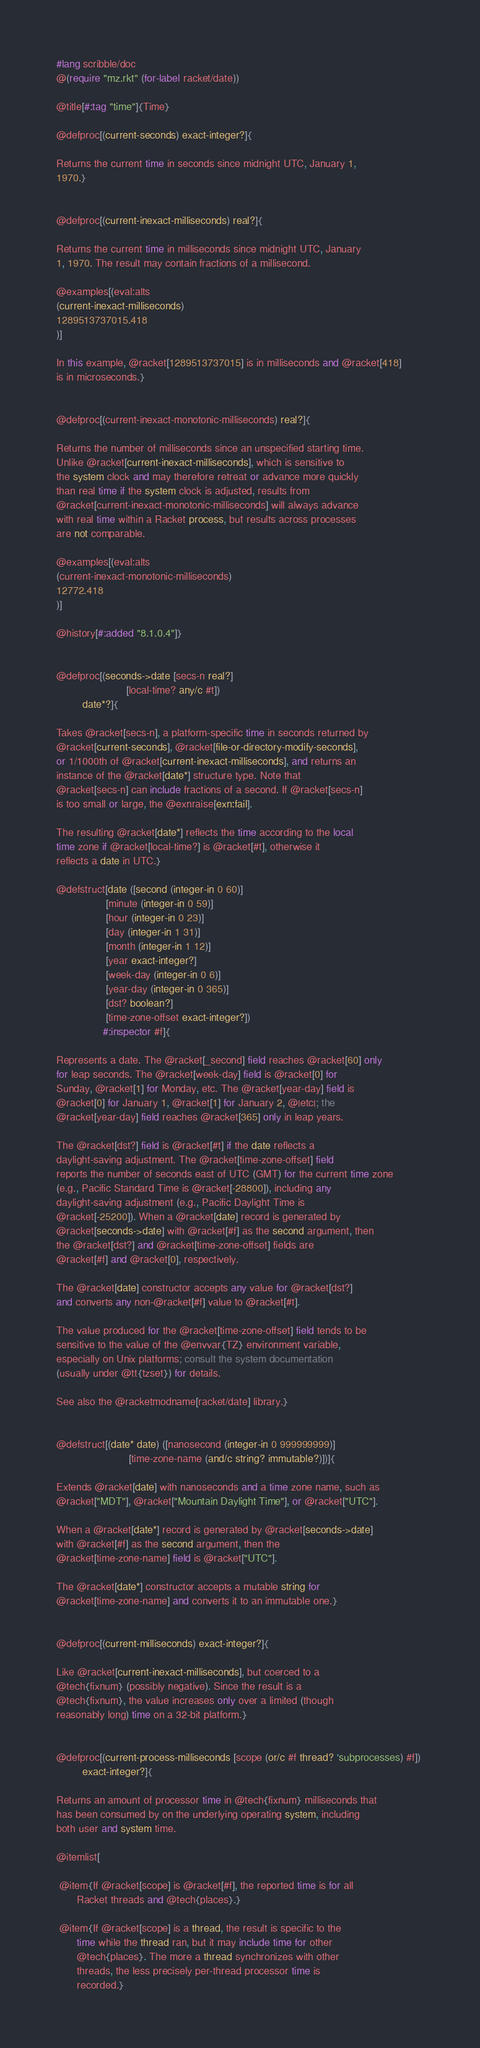<code> <loc_0><loc_0><loc_500><loc_500><_Racket_>#lang scribble/doc
@(require "mz.rkt" (for-label racket/date))

@title[#:tag "time"]{Time}

@defproc[(current-seconds) exact-integer?]{

Returns the current time in seconds since midnight UTC, January 1,
1970.}


@defproc[(current-inexact-milliseconds) real?]{

Returns the current time in milliseconds since midnight UTC, January
1, 1970. The result may contain fractions of a millisecond.

@examples[(eval:alts
(current-inexact-milliseconds)
1289513737015.418
)]

In this example, @racket[1289513737015] is in milliseconds and @racket[418]
is in microseconds.}


@defproc[(current-inexact-monotonic-milliseconds) real?]{

Returns the number of milliseconds since an unspecified starting time.
Unlike @racket[current-inexact-milliseconds], which is sensitive to
the system clock and may therefore retreat or advance more quickly
than real time if the system clock is adjusted, results from
@racket[current-inexact-monotonic-milliseconds] will always advance
with real time within a Racket process, but results across processes
are not comparable.

@examples[(eval:alts
(current-inexact-monotonic-milliseconds)
12772.418
)]

@history[#:added "8.1.0.4"]}


@defproc[(seconds->date [secs-n real?]
                        [local-time? any/c #t])
         date*?]{

Takes @racket[secs-n], a platform-specific time in seconds returned by
@racket[current-seconds], @racket[file-or-directory-modify-seconds],
or 1/1000th of @racket[current-inexact-milliseconds], and returns an
instance of the @racket[date*] structure type. Note that
@racket[secs-n] can include fractions of a second. If @racket[secs-n]
is too small or large, the @exnraise[exn:fail].

The resulting @racket[date*] reflects the time according to the local
time zone if @racket[local-time?] is @racket[#t], otherwise it
reflects a date in UTC.}

@defstruct[date ([second (integer-in 0 60)]
                 [minute (integer-in 0 59)]
                 [hour (integer-in 0 23)]
                 [day (integer-in 1 31)]
                 [month (integer-in 1 12)]
                 [year exact-integer?]
                 [week-day (integer-in 0 6)]
                 [year-day (integer-in 0 365)]
                 [dst? boolean?]
                 [time-zone-offset exact-integer?])
                #:inspector #f]{

Represents a date. The @racket[_second] field reaches @racket[60] only
for leap seconds. The @racket[week-day] field is @racket[0] for
Sunday, @racket[1] for Monday, etc. The @racket[year-day] field is
@racket[0] for January 1, @racket[1] for January 2, @|etc|; the
@racket[year-day] field reaches @racket[365] only in leap years.

The @racket[dst?] field is @racket[#t] if the date reflects a
daylight-saving adjustment. The @racket[time-zone-offset] field
reports the number of seconds east of UTC (GMT) for the current time zone
(e.g., Pacific Standard Time is @racket[-28800]), including any
daylight-saving adjustment (e.g., Pacific Daylight Time is
@racket[-25200]). When a @racket[date] record is generated by
@racket[seconds->date] with @racket[#f] as the second argument, then
the @racket[dst?] and @racket[time-zone-offset] fields are
@racket[#f] and @racket[0], respectively.

The @racket[date] constructor accepts any value for @racket[dst?]
and converts any non-@racket[#f] value to @racket[#t].

The value produced for the @racket[time-zone-offset] field tends to be
sensitive to the value of the @envvar{TZ} environment variable,
especially on Unix platforms; consult the system documentation
(usually under @tt{tzset}) for details.

See also the @racketmodname[racket/date] library.}


@defstruct[(date* date) ([nanosecond (integer-in 0 999999999)]
                         [time-zone-name (and/c string? immutable?)])]{

Extends @racket[date] with nanoseconds and a time zone name, such as
@racket["MDT"], @racket["Mountain Daylight Time"], or @racket["UTC"].

When a @racket[date*] record is generated by @racket[seconds->date]
with @racket[#f] as the second argument, then the
@racket[time-zone-name] field is @racket["UTC"].

The @racket[date*] constructor accepts a mutable string for
@racket[time-zone-name] and converts it to an immutable one.}


@defproc[(current-milliseconds) exact-integer?]{

Like @racket[current-inexact-milliseconds], but coerced to a
@tech{fixnum} (possibly negative). Since the result is a
@tech{fixnum}, the value increases only over a limited (though
reasonably long) time on a 32-bit platform.}


@defproc[(current-process-milliseconds [scope (or/c #f thread? 'subprocesses) #f]) 
         exact-integer?]{

Returns an amount of processor time in @tech{fixnum} milliseconds that
has been consumed by on the underlying operating system, including
both user and system time.

@itemlist[

 @item{If @racket[scope] is @racket[#f], the reported time is for all
       Racket threads and @tech{places}.}

 @item{If @racket[scope] is a thread, the result is specific to the
       time while the thread ran, but it may include time for other
       @tech{places}. The more a thread synchronizes with other
       threads, the less precisely per-thread processor time is
       recorded.}
</code> 